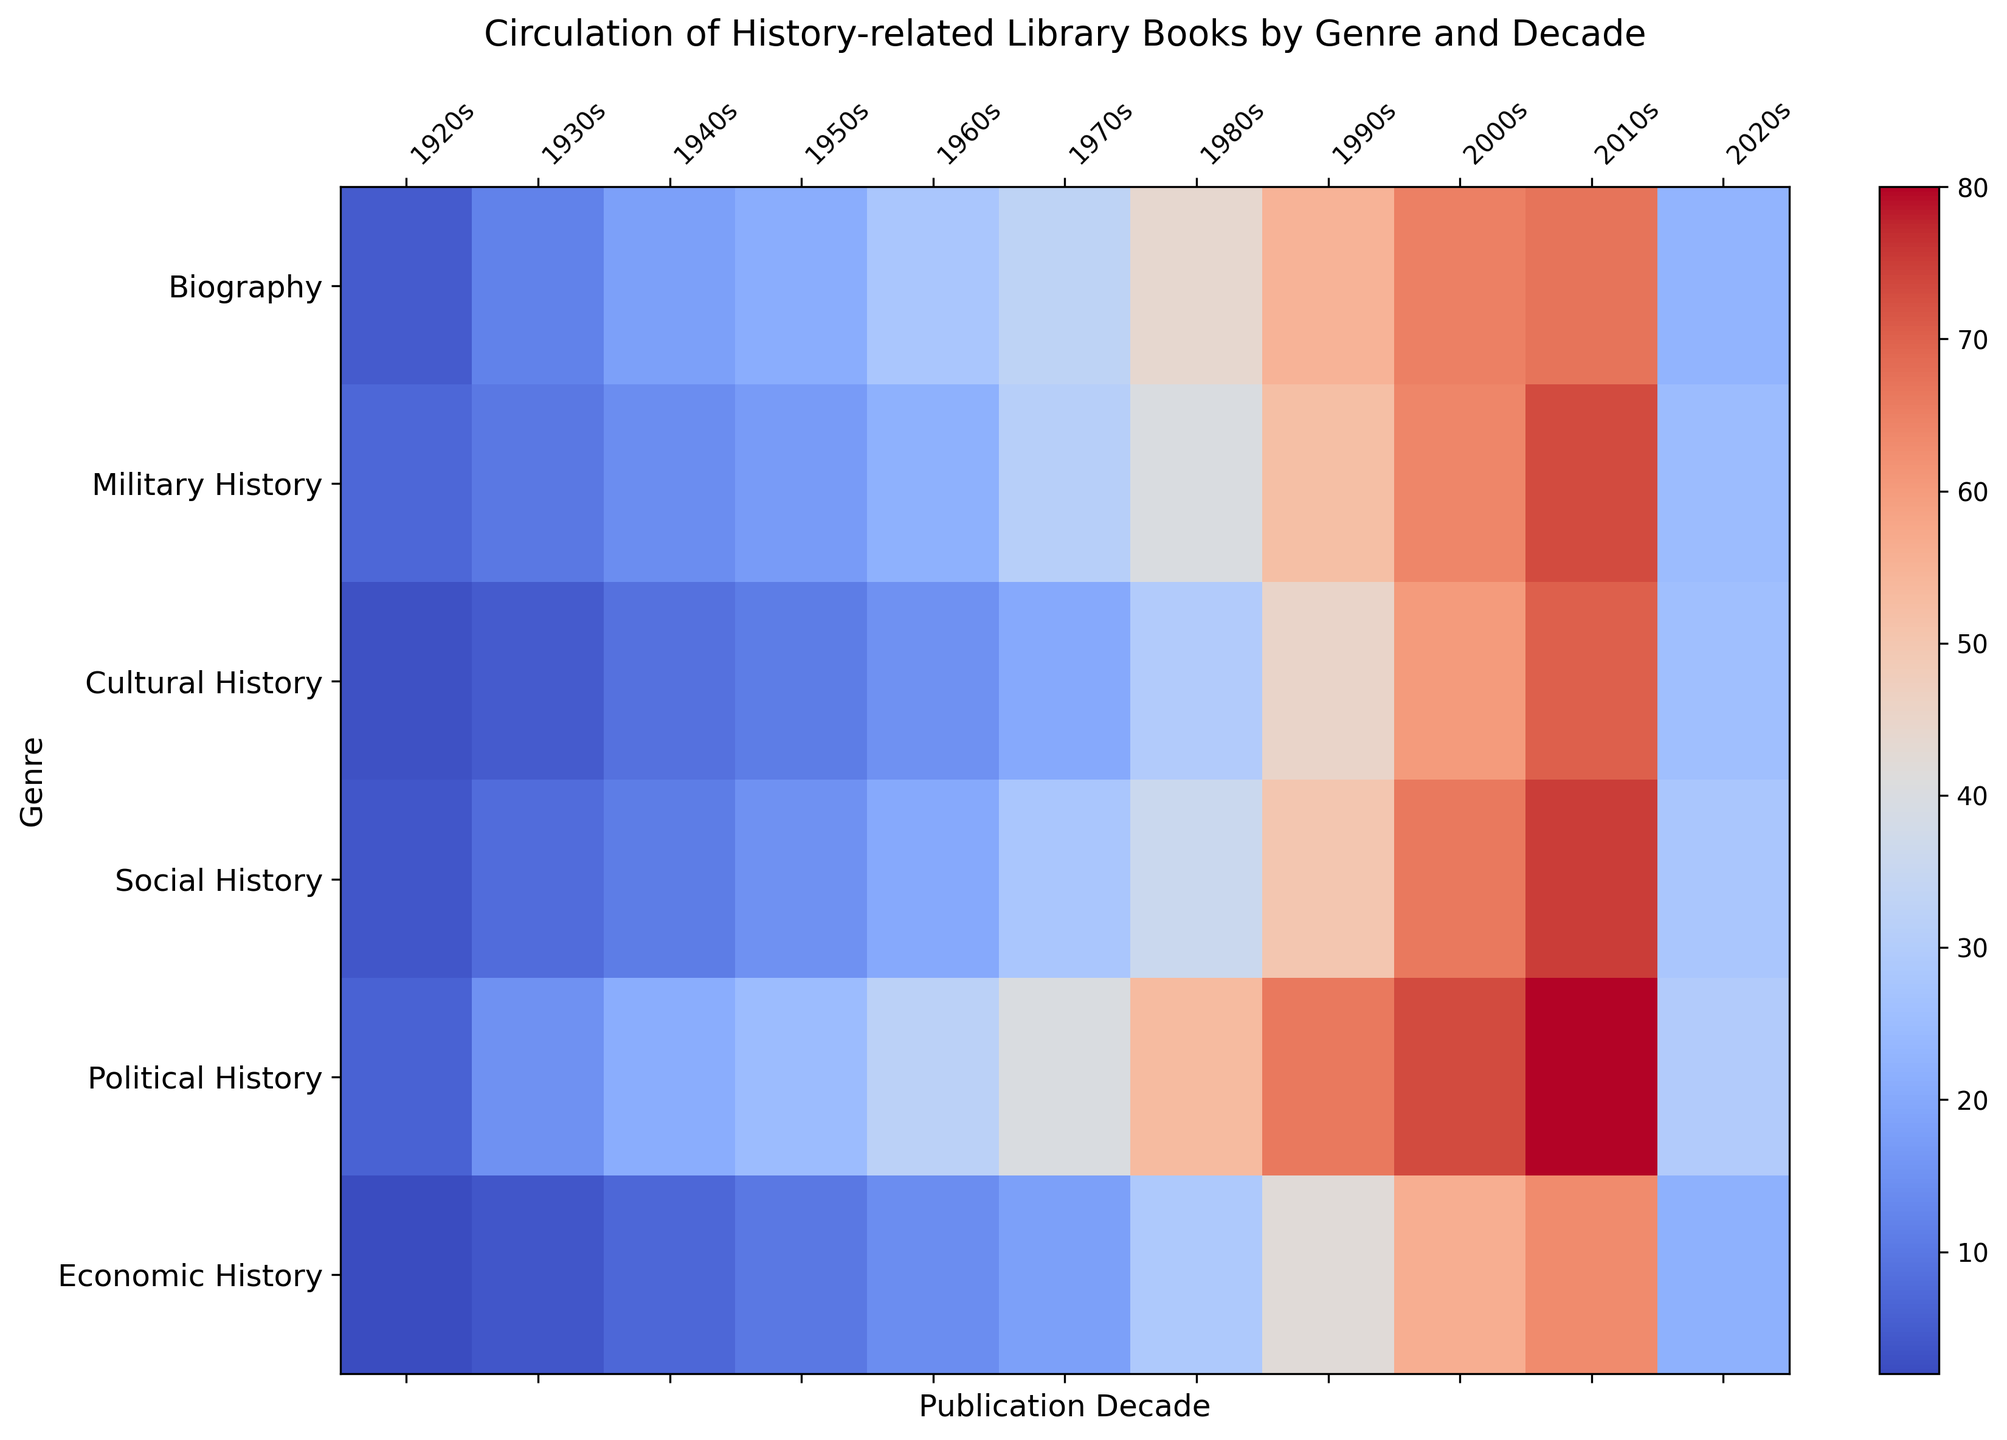Which genre had the highest circulation in the 2000s? Looking at the heatmap, locate the column for the 2000s and find the cell with the highest value. The highest value in the 2000s column is 73, which corresponds to Political History.
Answer: Political History Comparing the 1920s and the 2020s, how much did the circulation of Cultural History books increase? Identify the values for Cultural History in the 1920s and the 2020s. The values are 3 and 26, respectively. The increase can be calculated as 26 - 3 = 23.
Answer: 23 Which decade saw the highest circulation for Military History books? Locate the row for Military History and find the column with the highest value. The highest value in the row is 73, which corresponds to the 2010s.
Answer: 2010s What is the average circulation of Social History books across the decades? Sum the values in the Social History row: 4 + 8 + 11 + 15 + 20 + 28 + 36 + 50 + 66 + 75 + 28 = 341. There are 11 decades, so 341/11 = 31.
Answer: 31 What is the overall trend in the circulation of Economic History books from the 1920s to the 2020s? Observe the values in the Economic History row: 2, 4, 7, 10, 14, 18, 29, 42, 56, 63, 22. The values generally increase, peak in the 2010s, and then decrease.
Answer: Increase, then decrease Which genre had the least circulation in the 1930s? Locate the column for the 1930s and find the cell with the lowest value. The lowest value in the 1930s column is 4, which corresponds to Economic History.
Answer: Economic History By how much does the circulation of Biography books in the 2010s exceed that in the 1980s? Identify the values for Biography in the 2010s and the 1980s. The values are 67 and 44, respectively. The difference is 67 - 44 = 23.
Answer: 23 What is the sum of the circulations for Political History and Cultural History in the 1950s? Locate the values for Political History and Cultural History in the 1950s column. The values are 25 and 11, respectively. The sum is 25 + 11 = 36.
Answer: 36 Which genres have a higher circulation in the 1970s compared to their circulation in the 1980s? Compare the values in the 1970s and 1980s columns for each genre. All genres except Biography (33 < 44), Cultural History (20 < 30), and Political History (40 < 53) have higher circulation in the 1970s. Hence, only Economic History (18 > 29) does not fit.
Answer: None Is there a genre where the circulation peaked in the 1920s? Check the values for each genre in the 1920s and compare them with later decades. No genre has the highest value in its row as the 1920s.
Answer: No 